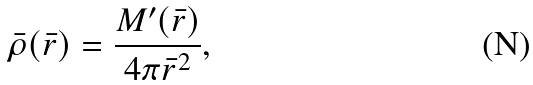<formula> <loc_0><loc_0><loc_500><loc_500>\bar { \rho } ( \bar { r } ) = \frac { M ^ { \prime } ( \bar { r } ) } { 4 \pi \bar { r } ^ { 2 } } ,</formula> 